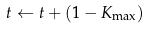Convert formula to latex. <formula><loc_0><loc_0><loc_500><loc_500>t \leftarrow t + ( 1 - K _ { \max } )</formula> 